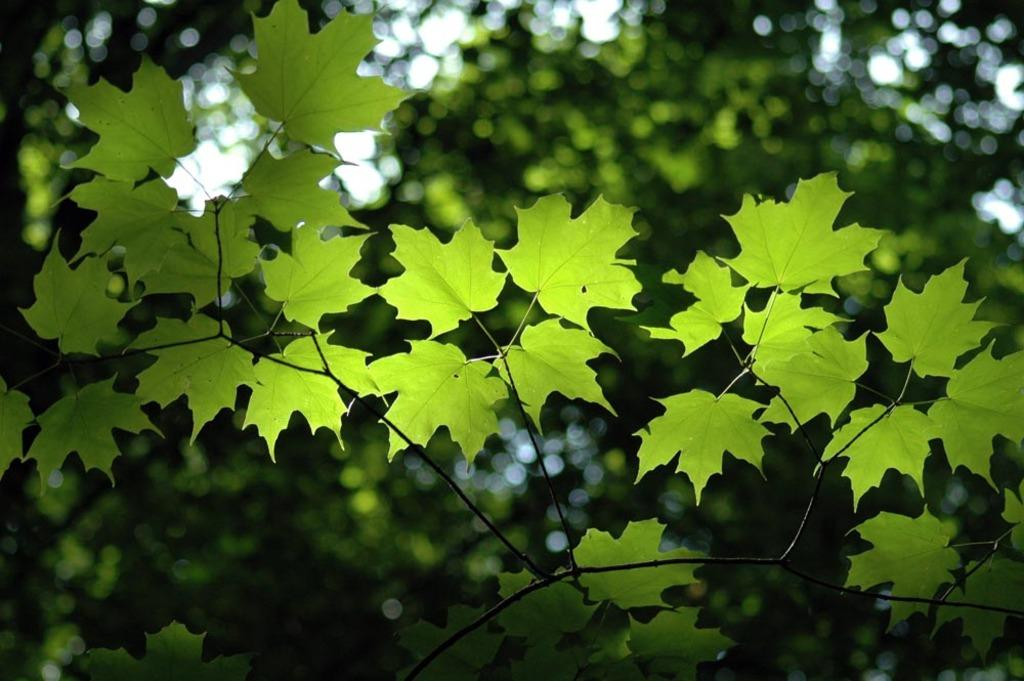What type of vegetation can be seen in the image? There are leaves and trees in the image. What part of the natural environment is visible in the image? The sky is visible in the image. How is the background of the image depicted? The background of the image is blurred. How many minutes are shown in the image? There are no minutes depicted in the image, as it features leaves, trees, the sky, and a blurred background. 